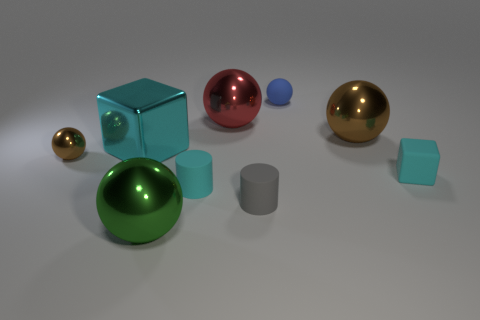Subtract all metallic spheres. How many spheres are left? 1 Add 1 green rubber cylinders. How many objects exist? 10 Subtract all cubes. How many objects are left? 7 Subtract all red cylinders. Subtract all gray balls. How many cylinders are left? 2 Subtract all cyan balls. How many gray cylinders are left? 1 Subtract all brown metal spheres. Subtract all tiny rubber cylinders. How many objects are left? 5 Add 6 tiny metal things. How many tiny metal things are left? 7 Add 1 red matte cylinders. How many red matte cylinders exist? 1 Subtract all blue spheres. How many spheres are left? 4 Subtract 2 brown balls. How many objects are left? 7 